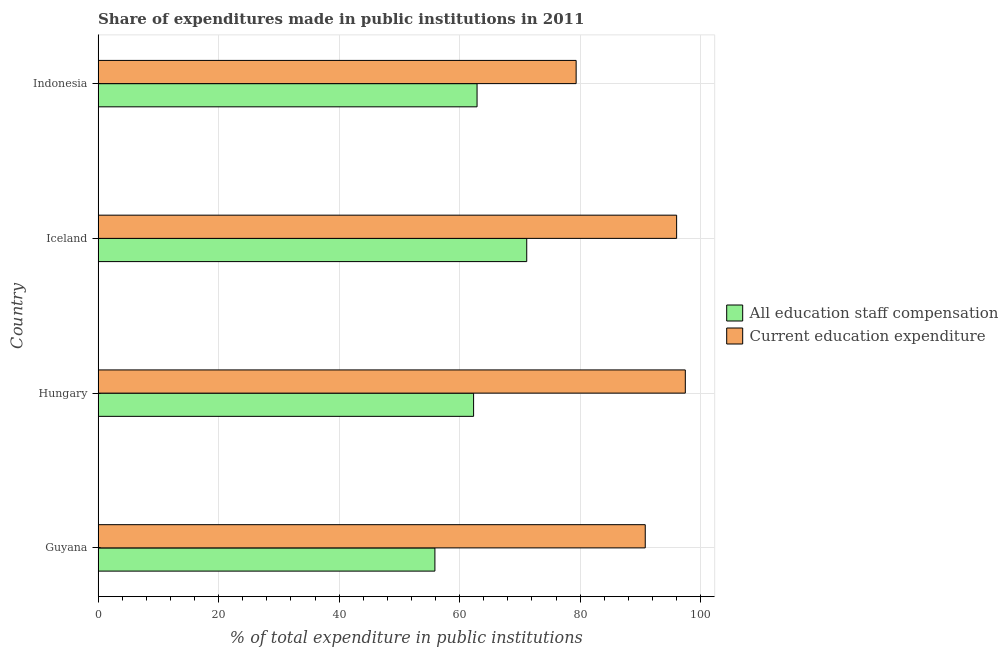How many bars are there on the 4th tick from the bottom?
Offer a terse response. 2. In how many cases, is the number of bars for a given country not equal to the number of legend labels?
Your answer should be very brief. 0. What is the expenditure in staff compensation in Hungary?
Ensure brevity in your answer.  62.32. Across all countries, what is the maximum expenditure in staff compensation?
Your answer should be compact. 71.14. Across all countries, what is the minimum expenditure in education?
Provide a succinct answer. 79.34. In which country was the expenditure in staff compensation maximum?
Keep it short and to the point. Iceland. What is the total expenditure in education in the graph?
Ensure brevity in your answer.  363.62. What is the difference between the expenditure in education in Guyana and that in Indonesia?
Your answer should be compact. 11.47. What is the difference between the expenditure in education in Guyana and the expenditure in staff compensation in Indonesia?
Provide a short and direct response. 27.92. What is the average expenditure in staff compensation per country?
Your answer should be very brief. 63.06. What is the difference between the expenditure in staff compensation and expenditure in education in Indonesia?
Ensure brevity in your answer.  -16.44. In how many countries, is the expenditure in education greater than 80 %?
Offer a very short reply. 3. Is the expenditure in education in Hungary less than that in Indonesia?
Ensure brevity in your answer.  No. What is the difference between the highest and the second highest expenditure in education?
Ensure brevity in your answer.  1.44. What is the difference between the highest and the lowest expenditure in education?
Provide a succinct answer. 18.12. Is the sum of the expenditure in education in Hungary and Indonesia greater than the maximum expenditure in staff compensation across all countries?
Give a very brief answer. Yes. What does the 2nd bar from the top in Iceland represents?
Offer a very short reply. All education staff compensation. What does the 2nd bar from the bottom in Guyana represents?
Give a very brief answer. Current education expenditure. Are all the bars in the graph horizontal?
Your answer should be very brief. Yes. How many countries are there in the graph?
Give a very brief answer. 4. What is the difference between two consecutive major ticks on the X-axis?
Your answer should be very brief. 20. Are the values on the major ticks of X-axis written in scientific E-notation?
Offer a terse response. No. Does the graph contain any zero values?
Your answer should be compact. No. Where does the legend appear in the graph?
Your answer should be very brief. Center right. How many legend labels are there?
Offer a terse response. 2. What is the title of the graph?
Provide a short and direct response. Share of expenditures made in public institutions in 2011. Does "Netherlands" appear as one of the legend labels in the graph?
Make the answer very short. No. What is the label or title of the X-axis?
Ensure brevity in your answer.  % of total expenditure in public institutions. What is the % of total expenditure in public institutions of All education staff compensation in Guyana?
Provide a short and direct response. 55.9. What is the % of total expenditure in public institutions in Current education expenditure in Guyana?
Make the answer very short. 90.81. What is the % of total expenditure in public institutions of All education staff compensation in Hungary?
Keep it short and to the point. 62.32. What is the % of total expenditure in public institutions of Current education expenditure in Hungary?
Keep it short and to the point. 97.46. What is the % of total expenditure in public institutions in All education staff compensation in Iceland?
Your response must be concise. 71.14. What is the % of total expenditure in public institutions in Current education expenditure in Iceland?
Your answer should be very brief. 96.02. What is the % of total expenditure in public institutions in All education staff compensation in Indonesia?
Provide a short and direct response. 62.89. What is the % of total expenditure in public institutions in Current education expenditure in Indonesia?
Provide a succinct answer. 79.34. Across all countries, what is the maximum % of total expenditure in public institutions in All education staff compensation?
Offer a very short reply. 71.14. Across all countries, what is the maximum % of total expenditure in public institutions in Current education expenditure?
Offer a terse response. 97.46. Across all countries, what is the minimum % of total expenditure in public institutions in All education staff compensation?
Offer a terse response. 55.9. Across all countries, what is the minimum % of total expenditure in public institutions of Current education expenditure?
Ensure brevity in your answer.  79.34. What is the total % of total expenditure in public institutions in All education staff compensation in the graph?
Ensure brevity in your answer.  252.25. What is the total % of total expenditure in public institutions of Current education expenditure in the graph?
Your response must be concise. 363.62. What is the difference between the % of total expenditure in public institutions in All education staff compensation in Guyana and that in Hungary?
Your response must be concise. -6.42. What is the difference between the % of total expenditure in public institutions in Current education expenditure in Guyana and that in Hungary?
Offer a terse response. -6.65. What is the difference between the % of total expenditure in public institutions of All education staff compensation in Guyana and that in Iceland?
Offer a very short reply. -15.24. What is the difference between the % of total expenditure in public institutions in Current education expenditure in Guyana and that in Iceland?
Keep it short and to the point. -5.21. What is the difference between the % of total expenditure in public institutions in All education staff compensation in Guyana and that in Indonesia?
Give a very brief answer. -7. What is the difference between the % of total expenditure in public institutions of Current education expenditure in Guyana and that in Indonesia?
Make the answer very short. 11.47. What is the difference between the % of total expenditure in public institutions in All education staff compensation in Hungary and that in Iceland?
Make the answer very short. -8.82. What is the difference between the % of total expenditure in public institutions in Current education expenditure in Hungary and that in Iceland?
Your answer should be very brief. 1.44. What is the difference between the % of total expenditure in public institutions of All education staff compensation in Hungary and that in Indonesia?
Offer a terse response. -0.57. What is the difference between the % of total expenditure in public institutions in Current education expenditure in Hungary and that in Indonesia?
Your answer should be very brief. 18.12. What is the difference between the % of total expenditure in public institutions in All education staff compensation in Iceland and that in Indonesia?
Your answer should be very brief. 8.24. What is the difference between the % of total expenditure in public institutions in Current education expenditure in Iceland and that in Indonesia?
Provide a succinct answer. 16.68. What is the difference between the % of total expenditure in public institutions in All education staff compensation in Guyana and the % of total expenditure in public institutions in Current education expenditure in Hungary?
Your response must be concise. -41.56. What is the difference between the % of total expenditure in public institutions of All education staff compensation in Guyana and the % of total expenditure in public institutions of Current education expenditure in Iceland?
Offer a terse response. -40.12. What is the difference between the % of total expenditure in public institutions of All education staff compensation in Guyana and the % of total expenditure in public institutions of Current education expenditure in Indonesia?
Make the answer very short. -23.44. What is the difference between the % of total expenditure in public institutions in All education staff compensation in Hungary and the % of total expenditure in public institutions in Current education expenditure in Iceland?
Your response must be concise. -33.7. What is the difference between the % of total expenditure in public institutions in All education staff compensation in Hungary and the % of total expenditure in public institutions in Current education expenditure in Indonesia?
Make the answer very short. -17.02. What is the difference between the % of total expenditure in public institutions of All education staff compensation in Iceland and the % of total expenditure in public institutions of Current education expenditure in Indonesia?
Offer a terse response. -8.2. What is the average % of total expenditure in public institutions of All education staff compensation per country?
Provide a succinct answer. 63.06. What is the average % of total expenditure in public institutions in Current education expenditure per country?
Offer a very short reply. 90.91. What is the difference between the % of total expenditure in public institutions in All education staff compensation and % of total expenditure in public institutions in Current education expenditure in Guyana?
Your response must be concise. -34.91. What is the difference between the % of total expenditure in public institutions in All education staff compensation and % of total expenditure in public institutions in Current education expenditure in Hungary?
Give a very brief answer. -35.14. What is the difference between the % of total expenditure in public institutions in All education staff compensation and % of total expenditure in public institutions in Current education expenditure in Iceland?
Your answer should be compact. -24.88. What is the difference between the % of total expenditure in public institutions of All education staff compensation and % of total expenditure in public institutions of Current education expenditure in Indonesia?
Provide a succinct answer. -16.44. What is the ratio of the % of total expenditure in public institutions in All education staff compensation in Guyana to that in Hungary?
Provide a short and direct response. 0.9. What is the ratio of the % of total expenditure in public institutions of Current education expenditure in Guyana to that in Hungary?
Offer a terse response. 0.93. What is the ratio of the % of total expenditure in public institutions in All education staff compensation in Guyana to that in Iceland?
Provide a succinct answer. 0.79. What is the ratio of the % of total expenditure in public institutions of Current education expenditure in Guyana to that in Iceland?
Give a very brief answer. 0.95. What is the ratio of the % of total expenditure in public institutions of All education staff compensation in Guyana to that in Indonesia?
Make the answer very short. 0.89. What is the ratio of the % of total expenditure in public institutions in Current education expenditure in Guyana to that in Indonesia?
Offer a terse response. 1.14. What is the ratio of the % of total expenditure in public institutions in All education staff compensation in Hungary to that in Iceland?
Your answer should be very brief. 0.88. What is the ratio of the % of total expenditure in public institutions in Current education expenditure in Hungary to that in Iceland?
Provide a succinct answer. 1.01. What is the ratio of the % of total expenditure in public institutions of All education staff compensation in Hungary to that in Indonesia?
Make the answer very short. 0.99. What is the ratio of the % of total expenditure in public institutions in Current education expenditure in Hungary to that in Indonesia?
Your answer should be very brief. 1.23. What is the ratio of the % of total expenditure in public institutions of All education staff compensation in Iceland to that in Indonesia?
Make the answer very short. 1.13. What is the ratio of the % of total expenditure in public institutions of Current education expenditure in Iceland to that in Indonesia?
Your response must be concise. 1.21. What is the difference between the highest and the second highest % of total expenditure in public institutions in All education staff compensation?
Your answer should be very brief. 8.24. What is the difference between the highest and the second highest % of total expenditure in public institutions in Current education expenditure?
Your response must be concise. 1.44. What is the difference between the highest and the lowest % of total expenditure in public institutions in All education staff compensation?
Your answer should be very brief. 15.24. What is the difference between the highest and the lowest % of total expenditure in public institutions in Current education expenditure?
Your answer should be very brief. 18.12. 